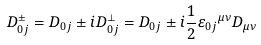<formula> <loc_0><loc_0><loc_500><loc_500>D ^ { \pm } _ { 0 j } = D _ { 0 j } \pm i D _ { 0 j } ^ { \perp } = D _ { 0 j } \pm i \frac { 1 } { 2 } { \varepsilon _ { 0 j } } ^ { \mu \nu } D _ { \mu \nu }</formula> 